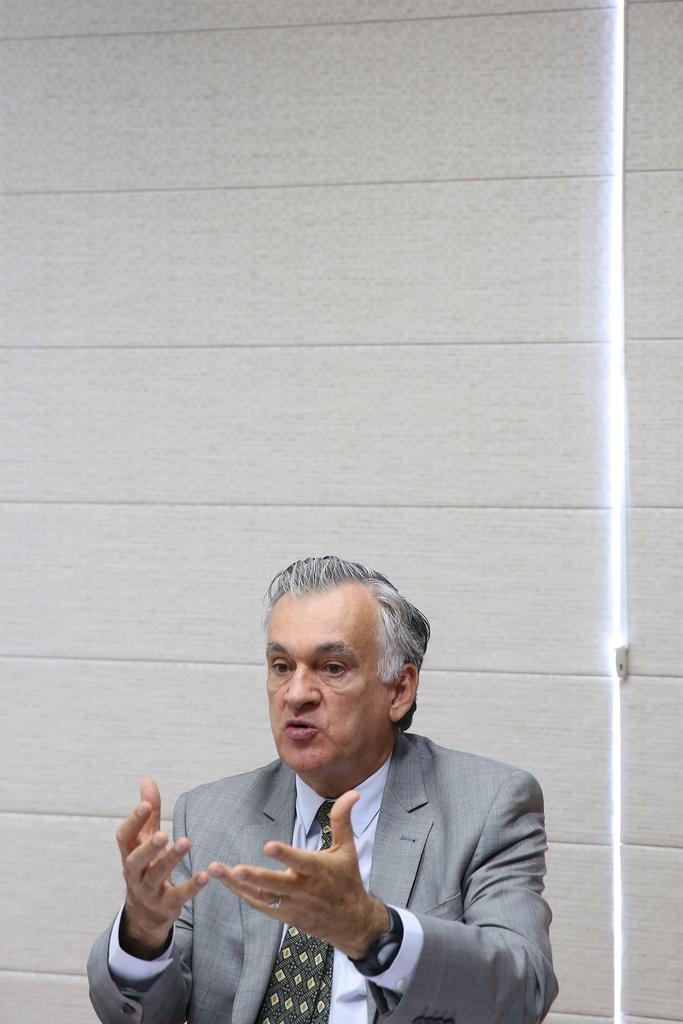Describe this image in one or two sentences. In this picture there is a person with grey suit is talking. At the back there's a wall. 